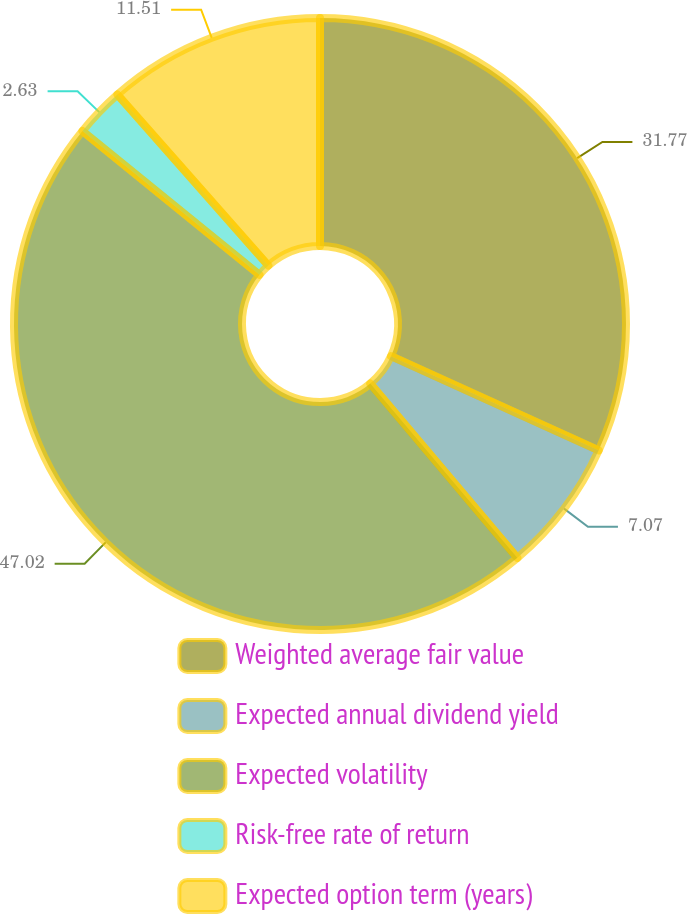Convert chart to OTSL. <chart><loc_0><loc_0><loc_500><loc_500><pie_chart><fcel>Weighted average fair value<fcel>Expected annual dividend yield<fcel>Expected volatility<fcel>Risk-free rate of return<fcel>Expected option term (years)<nl><fcel>31.77%<fcel>7.07%<fcel>47.01%<fcel>2.63%<fcel>11.51%<nl></chart> 